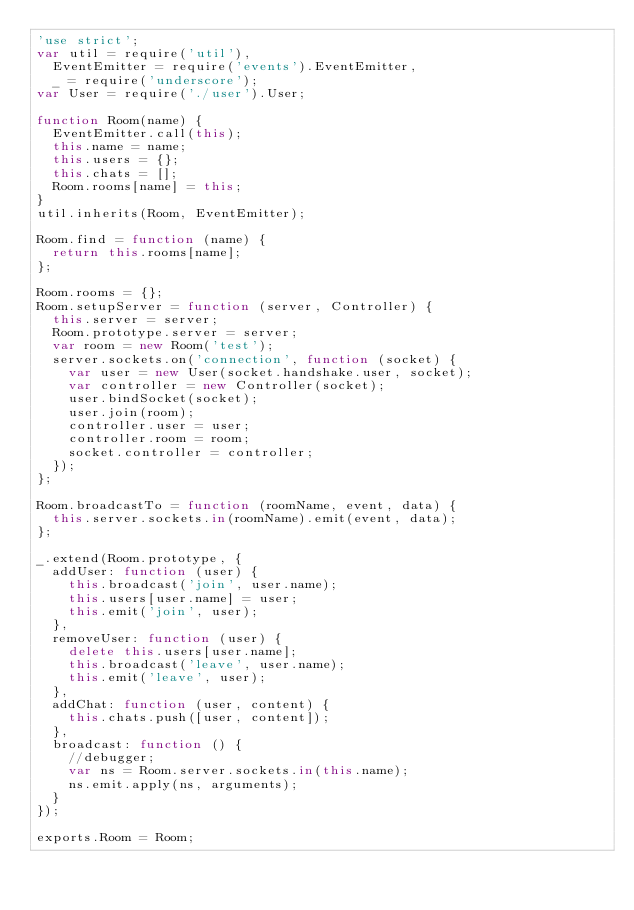Convert code to text. <code><loc_0><loc_0><loc_500><loc_500><_JavaScript_>'use strict';
var util = require('util'),
	EventEmitter = require('events').EventEmitter,
	_ = require('underscore');
var User = require('./user').User;

function Room(name) {
	EventEmitter.call(this);
	this.name = name;
	this.users = {};
	this.chats = [];
	Room.rooms[name] = this;
}
util.inherits(Room, EventEmitter);

Room.find = function (name) {
	return this.rooms[name];
};

Room.rooms = {};
Room.setupServer = function (server, Controller) {
	this.server = server;
	Room.prototype.server = server;
	var room = new Room('test');
	server.sockets.on('connection', function (socket) {
		var user = new User(socket.handshake.user, socket);
		var controller = new Controller(socket);
		user.bindSocket(socket);
		user.join(room);
		controller.user = user;
		controller.room = room;
		socket.controller = controller;
	});
};

Room.broadcastTo = function (roomName, event, data) {
	this.server.sockets.in(roomName).emit(event, data);
};

_.extend(Room.prototype, {
	addUser: function (user) {
		this.broadcast('join', user.name);
		this.users[user.name] = user;
		this.emit('join', user);
	},
	removeUser: function (user) {
		delete this.users[user.name];
		this.broadcast('leave', user.name);
		this.emit('leave', user);
	},
	addChat: function (user, content) {
		this.chats.push([user, content]);
	},
	broadcast: function () {
		//debugger;
		var ns = Room.server.sockets.in(this.name);
		ns.emit.apply(ns, arguments);
	}
});

exports.Room = Room;
</code> 